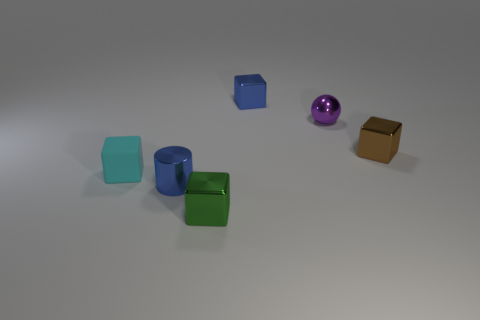Add 3 large gray balls. How many objects exist? 9 Subtract all balls. How many objects are left? 5 Add 4 big purple matte blocks. How many big purple matte blocks exist? 4 Subtract 0 yellow cubes. How many objects are left? 6 Subtract all big yellow matte spheres. Subtract all small green objects. How many objects are left? 5 Add 4 tiny blue metal cubes. How many tiny blue metal cubes are left? 5 